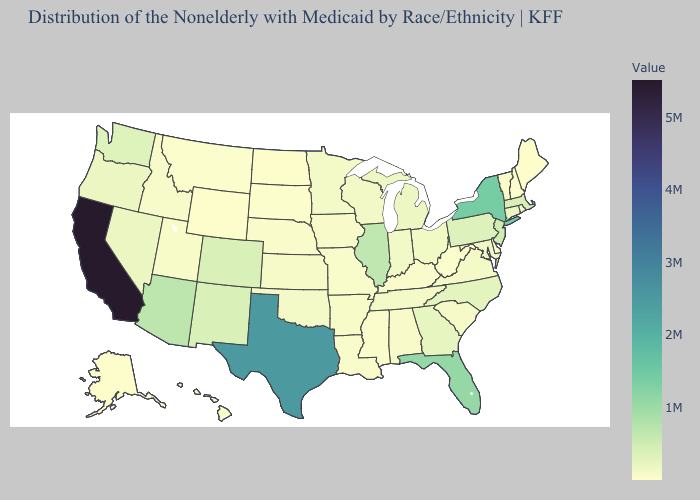Among the states that border South Carolina , does North Carolina have the lowest value?
Write a very short answer. No. Does the map have missing data?
Short answer required. No. Does Connecticut have the highest value in the Northeast?
Write a very short answer. No. Which states have the lowest value in the West?
Quick response, please. Wyoming. Is the legend a continuous bar?
Give a very brief answer. Yes. Does Illinois have the highest value in the MidWest?
Be succinct. Yes. Is the legend a continuous bar?
Keep it brief. Yes. Among the states that border Kansas , does Oklahoma have the highest value?
Give a very brief answer. No. 